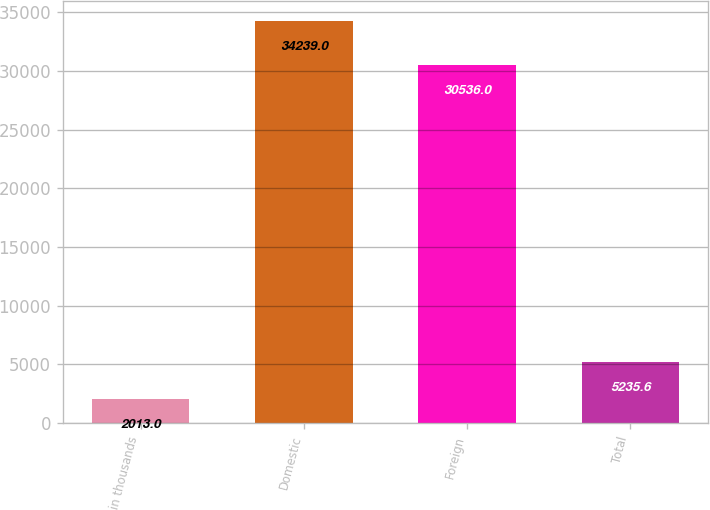Convert chart. <chart><loc_0><loc_0><loc_500><loc_500><bar_chart><fcel>in thousands<fcel>Domestic<fcel>Foreign<fcel>Total<nl><fcel>2013<fcel>34239<fcel>30536<fcel>5235.6<nl></chart> 